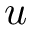<formula> <loc_0><loc_0><loc_500><loc_500>u</formula> 